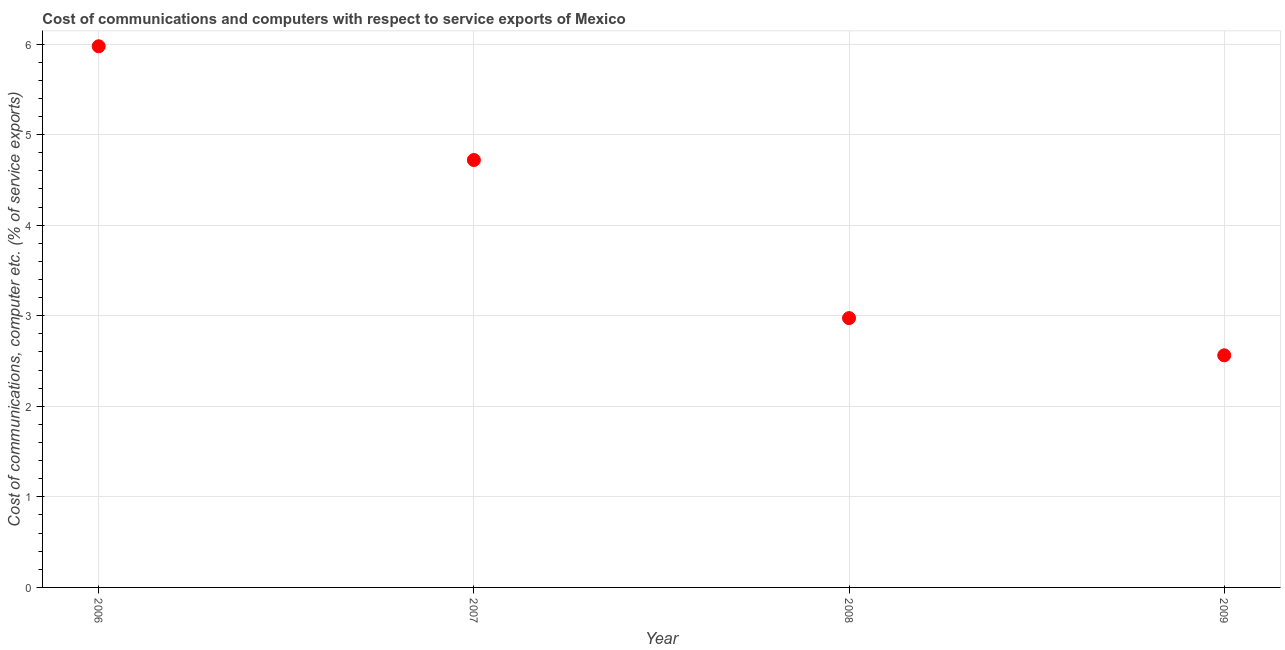What is the cost of communications and computer in 2007?
Provide a succinct answer. 4.72. Across all years, what is the maximum cost of communications and computer?
Your answer should be very brief. 5.98. Across all years, what is the minimum cost of communications and computer?
Your answer should be very brief. 2.56. In which year was the cost of communications and computer minimum?
Offer a terse response. 2009. What is the sum of the cost of communications and computer?
Offer a terse response. 16.23. What is the difference between the cost of communications and computer in 2006 and 2009?
Your answer should be compact. 3.41. What is the average cost of communications and computer per year?
Give a very brief answer. 4.06. What is the median cost of communications and computer?
Offer a terse response. 3.85. In how many years, is the cost of communications and computer greater than 0.2 %?
Your answer should be compact. 4. What is the ratio of the cost of communications and computer in 2006 to that in 2007?
Your answer should be very brief. 1.27. Is the cost of communications and computer in 2008 less than that in 2009?
Ensure brevity in your answer.  No. Is the difference between the cost of communications and computer in 2007 and 2009 greater than the difference between any two years?
Ensure brevity in your answer.  No. What is the difference between the highest and the second highest cost of communications and computer?
Give a very brief answer. 1.26. What is the difference between the highest and the lowest cost of communications and computer?
Offer a very short reply. 3.41. In how many years, is the cost of communications and computer greater than the average cost of communications and computer taken over all years?
Offer a very short reply. 2. Does the cost of communications and computer monotonically increase over the years?
Your response must be concise. No. How many dotlines are there?
Keep it short and to the point. 1. How many years are there in the graph?
Provide a succinct answer. 4. Does the graph contain any zero values?
Ensure brevity in your answer.  No. What is the title of the graph?
Make the answer very short. Cost of communications and computers with respect to service exports of Mexico. What is the label or title of the X-axis?
Make the answer very short. Year. What is the label or title of the Y-axis?
Give a very brief answer. Cost of communications, computer etc. (% of service exports). What is the Cost of communications, computer etc. (% of service exports) in 2006?
Your response must be concise. 5.98. What is the Cost of communications, computer etc. (% of service exports) in 2007?
Provide a succinct answer. 4.72. What is the Cost of communications, computer etc. (% of service exports) in 2008?
Give a very brief answer. 2.97. What is the Cost of communications, computer etc. (% of service exports) in 2009?
Offer a very short reply. 2.56. What is the difference between the Cost of communications, computer etc. (% of service exports) in 2006 and 2007?
Give a very brief answer. 1.26. What is the difference between the Cost of communications, computer etc. (% of service exports) in 2006 and 2008?
Keep it short and to the point. 3. What is the difference between the Cost of communications, computer etc. (% of service exports) in 2006 and 2009?
Give a very brief answer. 3.41. What is the difference between the Cost of communications, computer etc. (% of service exports) in 2007 and 2008?
Make the answer very short. 1.75. What is the difference between the Cost of communications, computer etc. (% of service exports) in 2007 and 2009?
Your answer should be compact. 2.16. What is the difference between the Cost of communications, computer etc. (% of service exports) in 2008 and 2009?
Provide a succinct answer. 0.41. What is the ratio of the Cost of communications, computer etc. (% of service exports) in 2006 to that in 2007?
Offer a very short reply. 1.27. What is the ratio of the Cost of communications, computer etc. (% of service exports) in 2006 to that in 2008?
Your answer should be very brief. 2.01. What is the ratio of the Cost of communications, computer etc. (% of service exports) in 2006 to that in 2009?
Offer a very short reply. 2.33. What is the ratio of the Cost of communications, computer etc. (% of service exports) in 2007 to that in 2008?
Offer a terse response. 1.59. What is the ratio of the Cost of communications, computer etc. (% of service exports) in 2007 to that in 2009?
Offer a terse response. 1.84. What is the ratio of the Cost of communications, computer etc. (% of service exports) in 2008 to that in 2009?
Give a very brief answer. 1.16. 